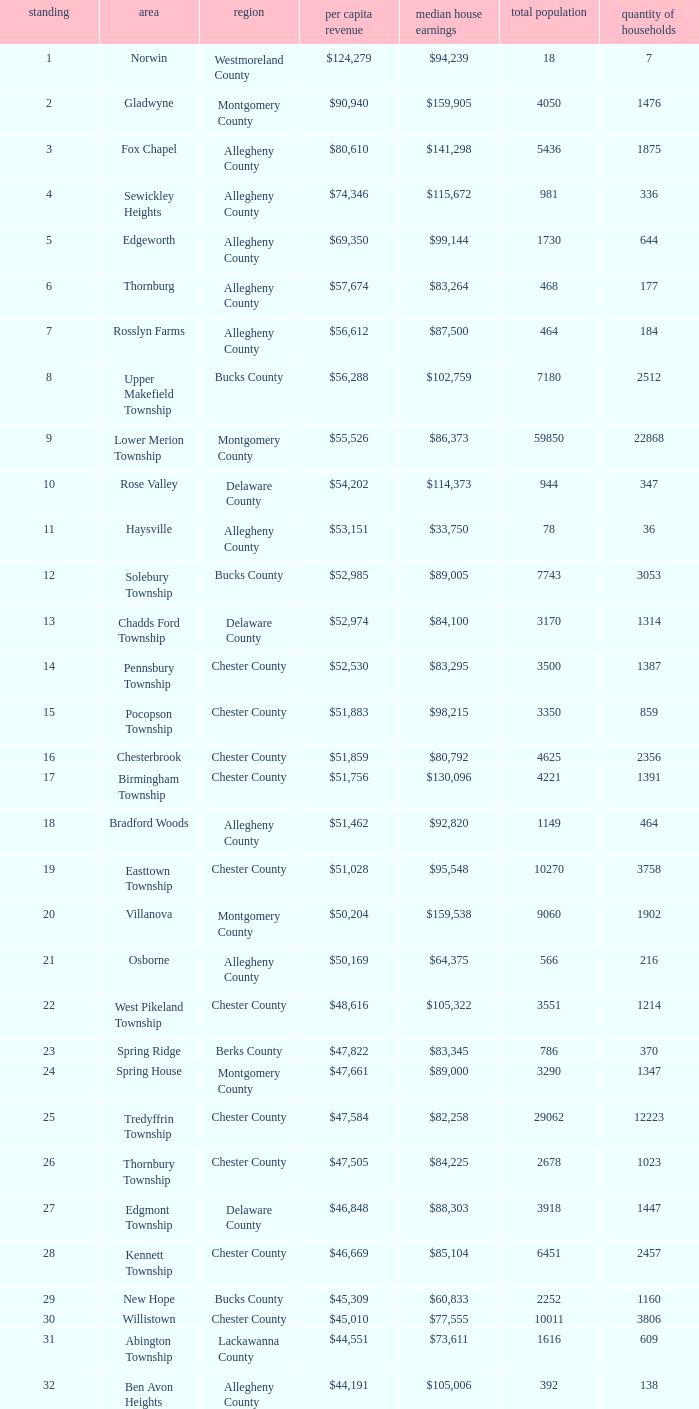What is the per capita income for Fayette County? $42,131. 